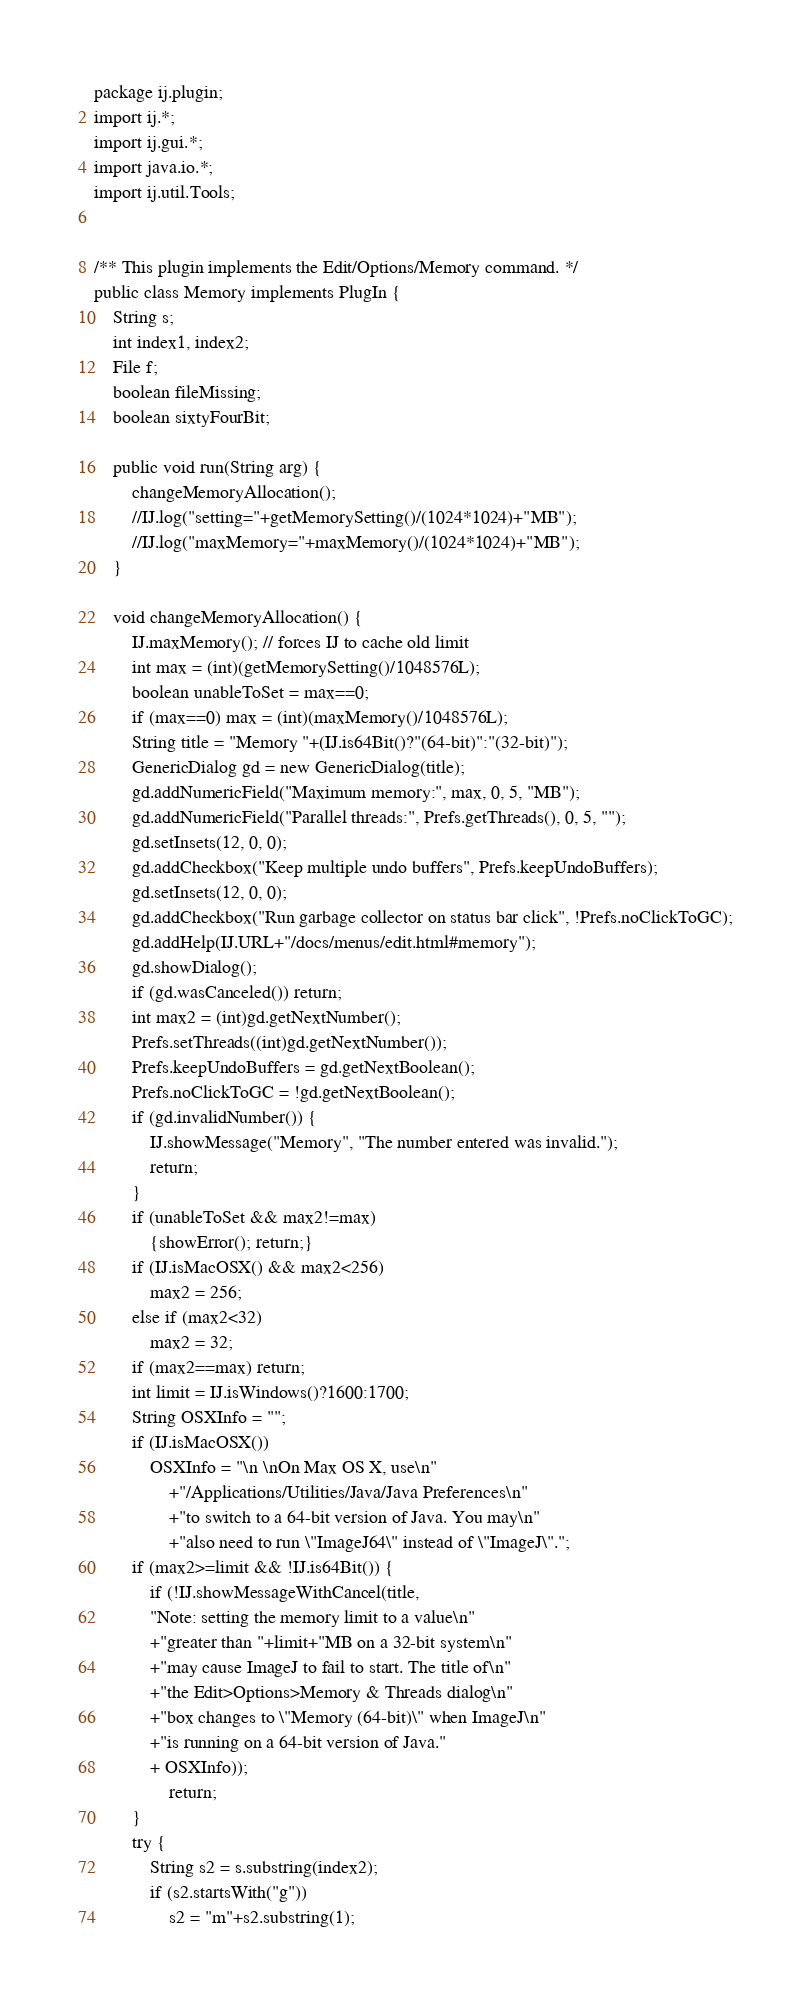<code> <loc_0><loc_0><loc_500><loc_500><_Java_>package ij.plugin;
import ij.*;
import ij.gui.*;
import java.io.*;
import ij.util.Tools;


/** This plugin implements the Edit/Options/Memory command. */
public class Memory implements PlugIn {
	String s;
	int index1, index2;
	File f;
	boolean fileMissing;
	boolean sixtyFourBit;

	public void run(String arg) {
		changeMemoryAllocation();
		//IJ.log("setting="+getMemorySetting()/(1024*1024)+"MB");
		//IJ.log("maxMemory="+maxMemory()/(1024*1024)+"MB");
	}

	void changeMemoryAllocation() {
		IJ.maxMemory(); // forces IJ to cache old limit
		int max = (int)(getMemorySetting()/1048576L);
		boolean unableToSet = max==0;
		if (max==0) max = (int)(maxMemory()/1048576L);
		String title = "Memory "+(IJ.is64Bit()?"(64-bit)":"(32-bit)");
		GenericDialog gd = new GenericDialog(title);
		gd.addNumericField("Maximum memory:", max, 0, 5, "MB");
		gd.addNumericField("Parallel threads:", Prefs.getThreads(), 0, 5, "");
		gd.setInsets(12, 0, 0);
		gd.addCheckbox("Keep multiple undo buffers", Prefs.keepUndoBuffers);
		gd.setInsets(12, 0, 0);
		gd.addCheckbox("Run garbage collector on status bar click", !Prefs.noClickToGC);
		gd.addHelp(IJ.URL+"/docs/menus/edit.html#memory");
		gd.showDialog();
		if (gd.wasCanceled()) return;
		int max2 = (int)gd.getNextNumber();
		Prefs.setThreads((int)gd.getNextNumber());
		Prefs.keepUndoBuffers = gd.getNextBoolean();
		Prefs.noClickToGC = !gd.getNextBoolean();
		if (gd.invalidNumber()) {
			IJ.showMessage("Memory", "The number entered was invalid.");
			return;
		}
		if (unableToSet && max2!=max)
			{showError(); return;}
		if (IJ.isMacOSX() && max2<256)
			max2 = 256;
		else if (max2<32)
			max2 = 32;
		if (max2==max) return;
		int limit = IJ.isWindows()?1600:1700;
		String OSXInfo = "";
		if (IJ.isMacOSX())
			OSXInfo = "\n \nOn Max OS X, use\n"
				+"/Applications/Utilities/Java/Java Preferences\n"
				+"to switch to a 64-bit version of Java. You may\n"
				+"also need to run \"ImageJ64\" instead of \"ImageJ\".";
		if (max2>=limit && !IJ.is64Bit()) {
			if (!IJ.showMessageWithCancel(title, 
			"Note: setting the memory limit to a value\n"
			+"greater than "+limit+"MB on a 32-bit system\n"
			+"may cause ImageJ to fail to start. The title of\n"
			+"the Edit>Options>Memory & Threads dialog\n"
			+"box changes to \"Memory (64-bit)\" when ImageJ\n"
			+"is running on a 64-bit version of Java."
			+ OSXInfo));
				return;
		}
		try {
			String s2 = s.substring(index2);
			if (s2.startsWith("g"))
				s2 = "m"+s2.substring(1);</code> 